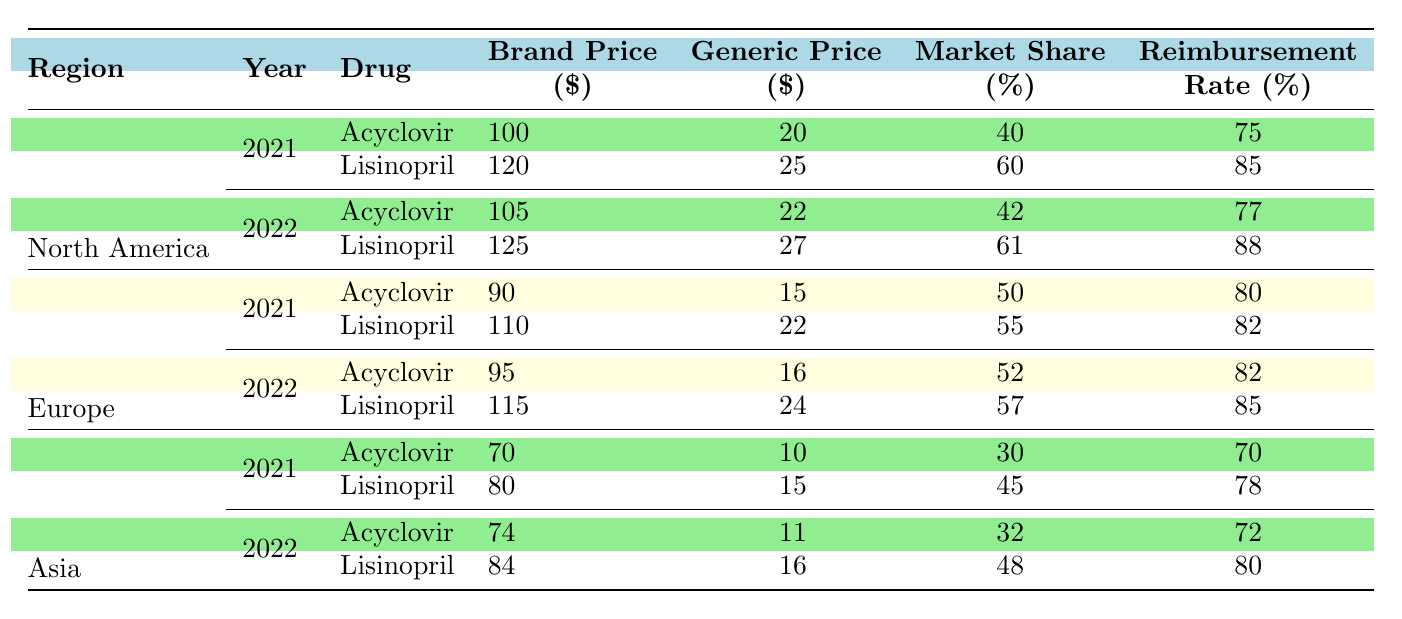What were the brand prices for Acyclovir in 2022 in North America? According to the table, the brand price for Acyclovir in North America in 2022 is listed as 105 dollars.
Answer: 105 What is the generic price difference for Lisinopril between 2021 and 2022 in Europe? The generic price for Lisinopril in Europe for 2021 is 22 dollars and for 2022 is 24 dollars. The difference is calculated as 24 - 22 = 2 dollars.
Answer: 2 Which region had the highest market share for Acyclovir in 2021? The market shares for Acyclovir in 2021 are 40% for North America, 50% for Europe, and 30% for Asia. The highest is 50% in Europe.
Answer: Europe What was the reimbursement rate for Lisinopril in Asia in 2022? The reimbursement rate for Lisinopril in Asia in 2022 is directly listed in the table as 80%.
Answer: 80 How much was the total reimbursement rate for Acyclovir in North America for both 2021 and 2022 combined? The reimbursement rates for Acyclovir in North America are 75% for 2021 and 77% for 2022. To find the total, we add both rates: 75 + 77 = 152%.
Answer: 152 Which drug had a higher brand price in 2021 in Asia, and by how much? In 2021, Acyclovir had a brand price of 70 dollars and Lisinopril had a brand price of 80 dollars in Asia. To find the difference, we calculate 80 - 70 = 10 dollars; therefore, Lisinopril had a higher price.
Answer: 10 Did the market share for Acyclovir in North America increase or decrease from 2021 to 2022? The market share for Acyclovir in North America was 40% in 2021 and decreased to 42% in 2022. Thus, it increased, as 42 is greater than 40.
Answer: Increased What is the average generic price for both Acyclovir and Lisinopril in Europe for 2021? The generic prices for Acyclovir and Lisinopril in Europe in 2021 are 15 and 22 dollars, respectively. The average is calculated as (15 + 22) / 2 = 18.5 dollars.
Answer: 18.5 Which region had a lower reimbursement rate for Lisinopril in 2022, and by how much compared to North America? The reimbursement rate for Lisinopril in Asia is 80% in 2022, while in North America, it is 88%. The difference is 88 - 80 = 8%. Thus, Asia had a lower rate by that amount.
Answer: Asia, 8 What was the market share for Lisinopril in North America for 2021? The market share for Lisinopril in North America in 2021 is stated in the table as 60%.
Answer: 60 